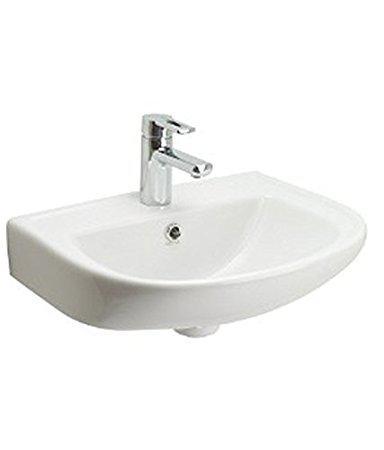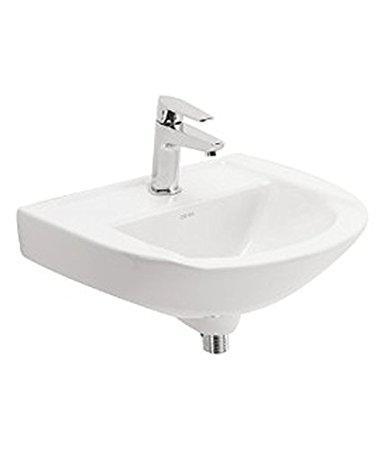The first image is the image on the left, the second image is the image on the right. Examine the images to the left and right. Is the description "Each sink has a rounded outer edge and back edge that fits parallel to a wall." accurate? Answer yes or no. Yes. 